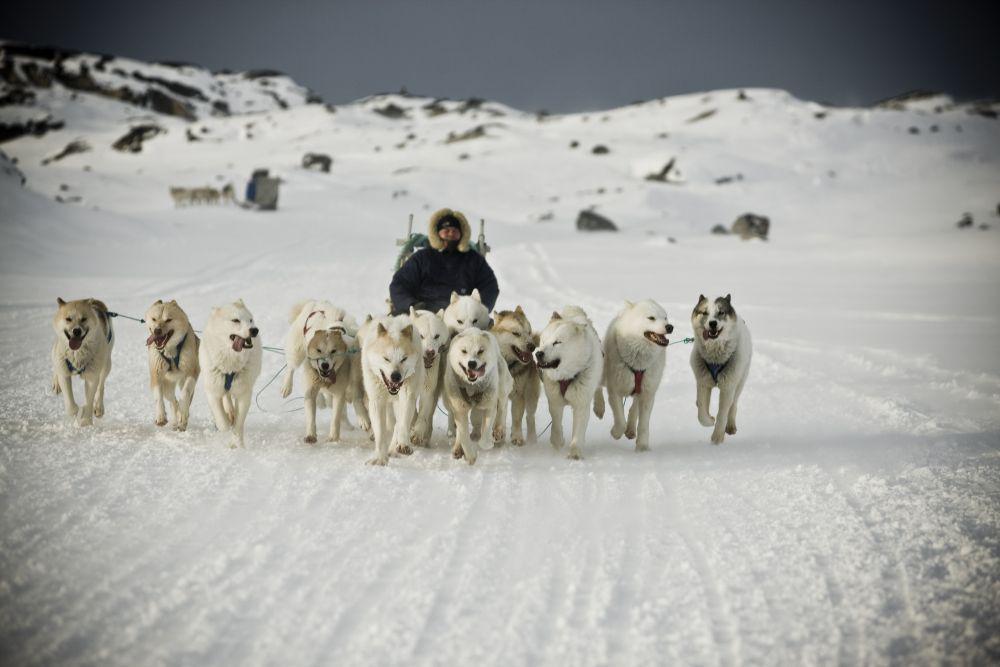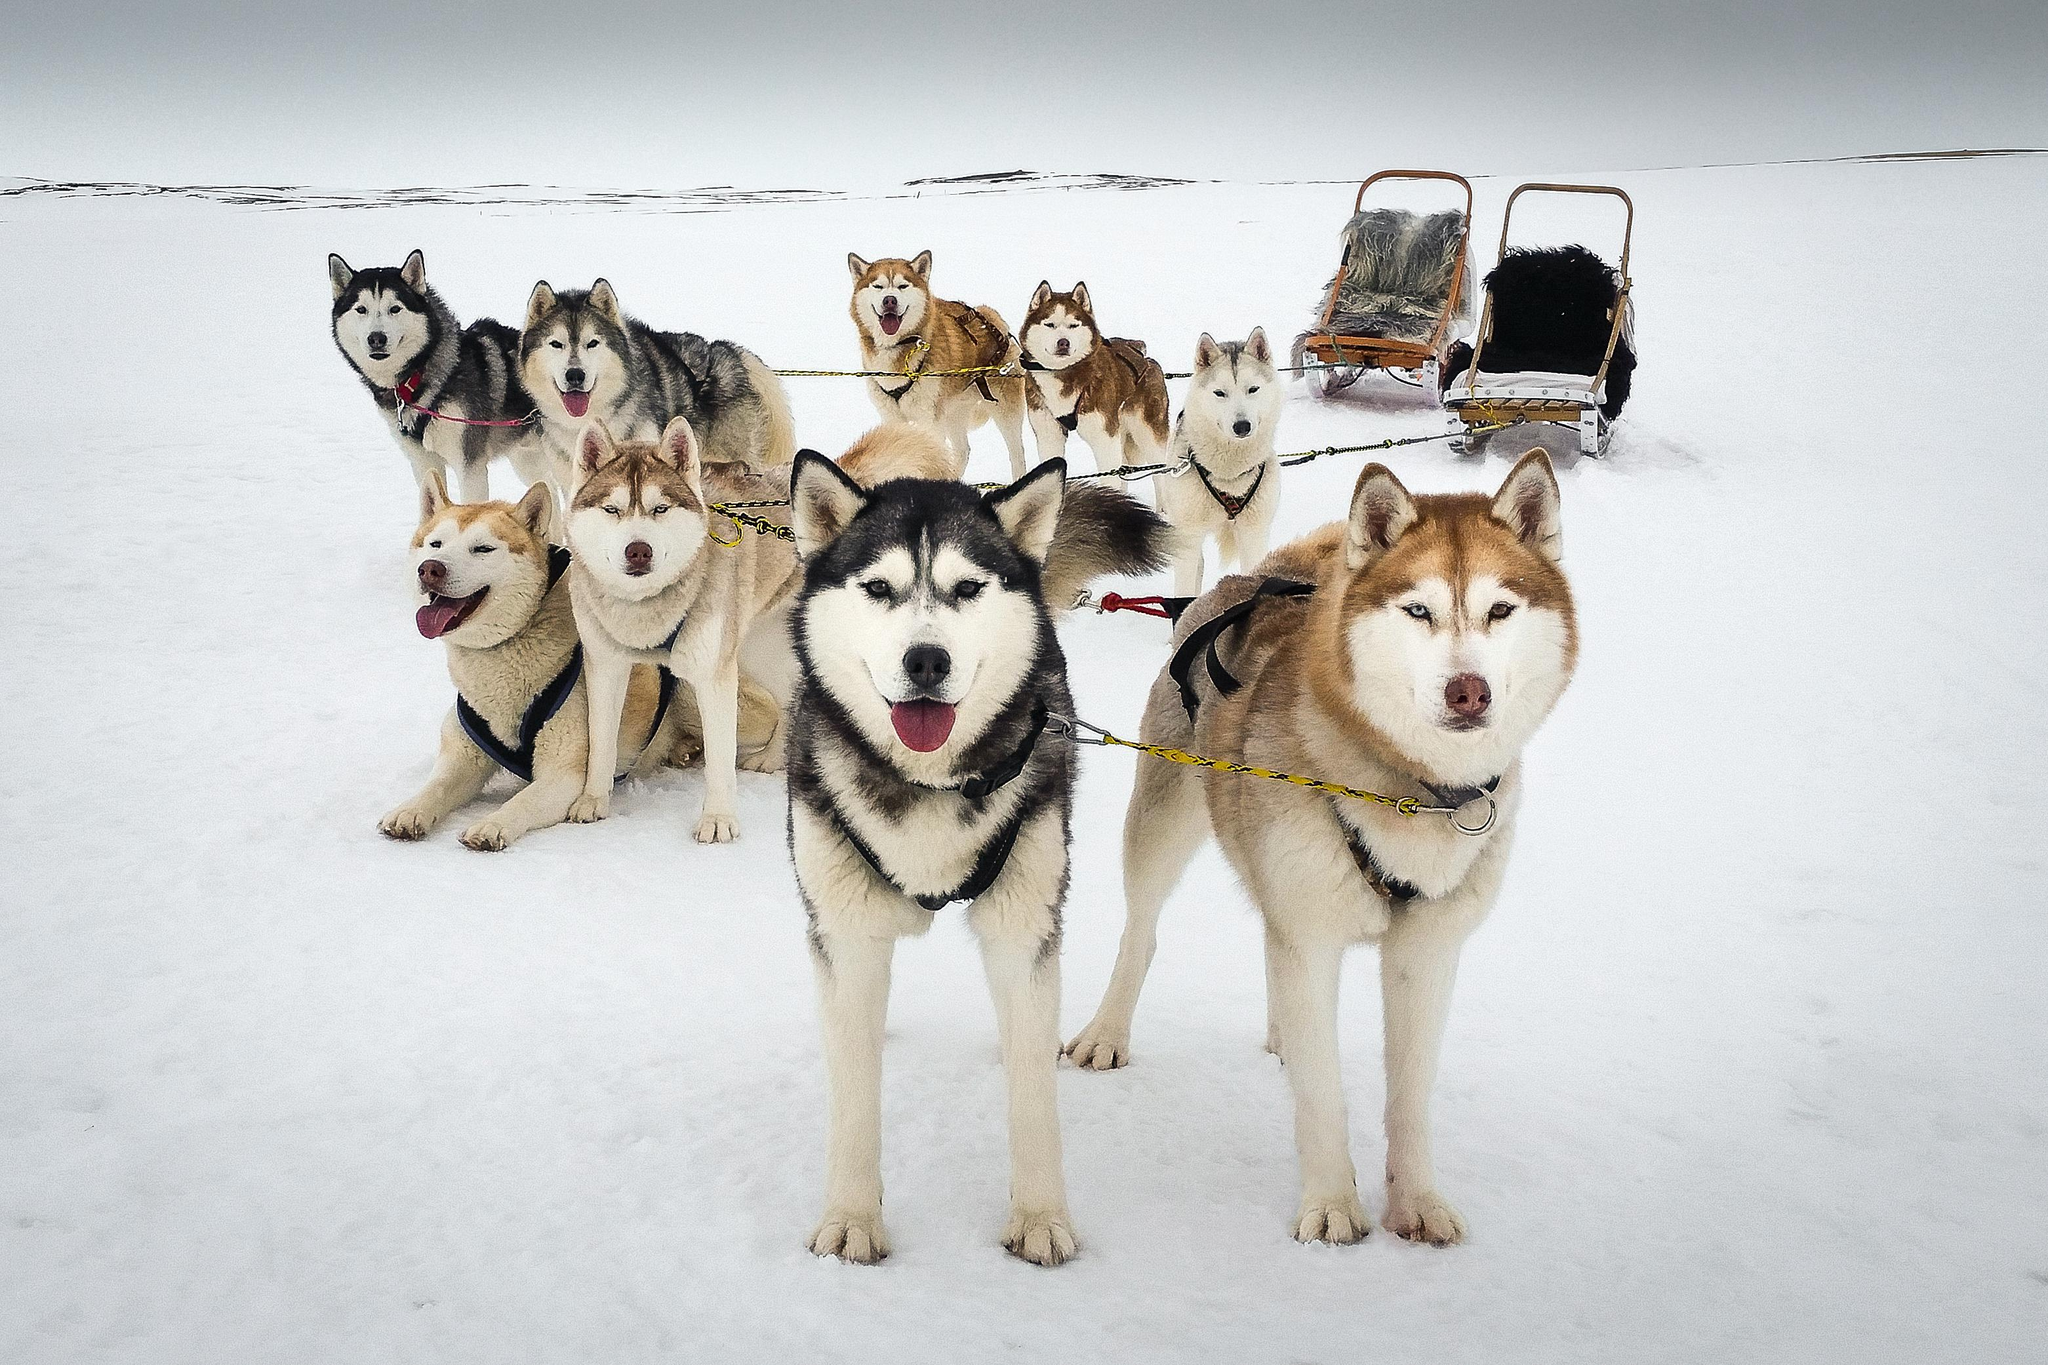The first image is the image on the left, the second image is the image on the right. Analyze the images presented: Is the assertion "In one image, mountains form the backdrop to the sled dog team." valid? Answer yes or no. Yes. The first image is the image on the left, the second image is the image on the right. Examine the images to the left and right. Is the description "At least one of the sleds is empty." accurate? Answer yes or no. Yes. 